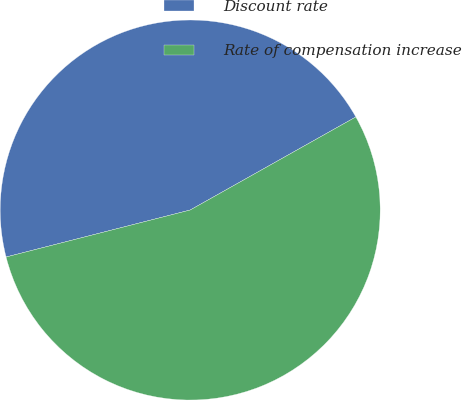Convert chart. <chart><loc_0><loc_0><loc_500><loc_500><pie_chart><fcel>Discount rate<fcel>Rate of compensation increase<nl><fcel>45.83%<fcel>54.17%<nl></chart> 